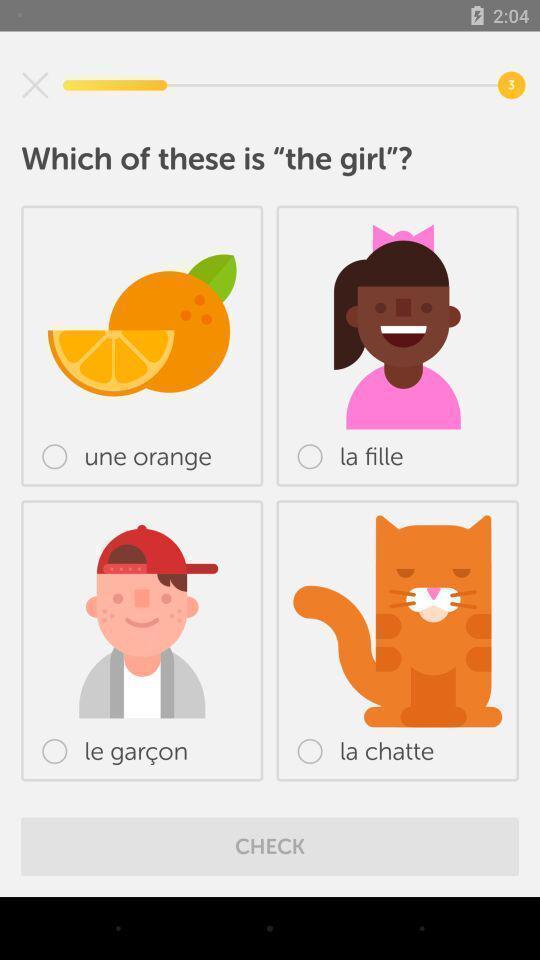Explain the elements present in this screenshot. Screen displaying various images on language learning app. 